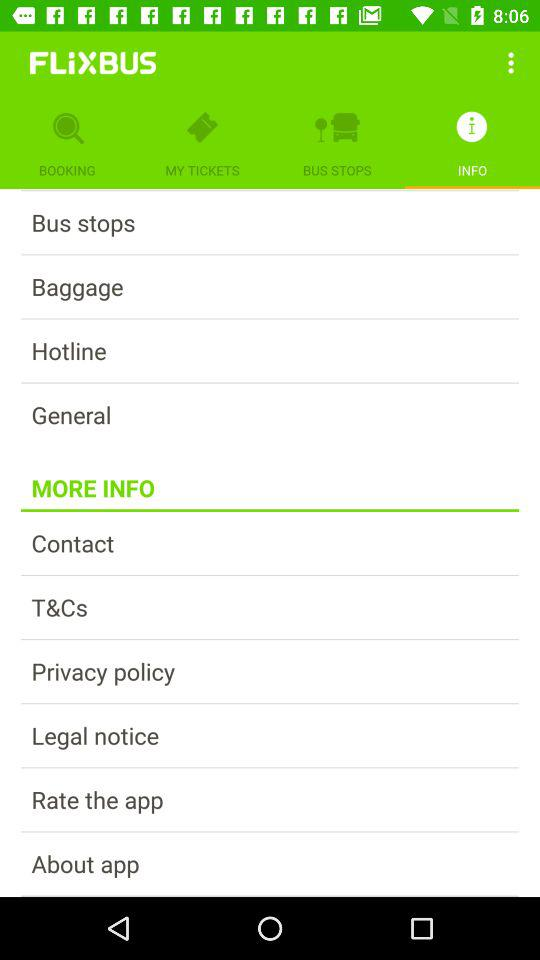Which tab is open? The open tab is "INFO". 